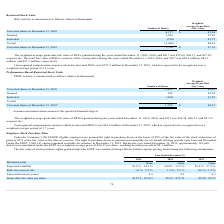According to Cornerstone Ondemand's financial document, What was the weighted average grant date fair value of RSUs during 2019? According to the financial document, $55.69. The relevant text states: "years ended December 31, 2019, 2018, and 2017 was $55.69, $46.17, and $37.99,..." Also, What was the number of granted shares? According to the financial document, 1,589 (in thousands). The relevant text states: "Granted 1,589 55.69..." Also, What was the unrecognized compensation expense related to unvested RSUs in 2019? According to the financial document, $127.2 million. The relevant text states: "compensation expense related to unvested RSUs was $127.2 million at December 31, 2019, which is expected to be recognized over a..." Also, can you calculate: What is the change in number of unvested shares between 2018 and 2019? Based on the calculation: (3,756-4,117), the result is -361 (in thousands). This is based on the information: "Unvested shares at December 31, 2018 4,117 $ 41.94 Unvested shares at December 31, 2019 3,756 $ 47.76..." The key data points involved are: 3,756, 4,117. Also, can you calculate: What is the difference in weighted-average grant date fair value between granted and forfeited shares? Based on the calculation: (55.69-45.72), the result is 9.97. This is based on the information: "Forfeited (510) 45.72 Granted 1,589 55.69..." The key data points involved are: 45.72, 55.69. Also, can you calculate: What is the difference in weighted-average grant date fair value for unvested shares in 2018 and vested shares? Based on the calculation: (41.94-40.61), the result is 1.33. This is based on the information: "Vested (1,440) 40.61 Unvested shares at December 31, 2018 4,117 $ 41.94..." The key data points involved are: 40.61, 41.94. 